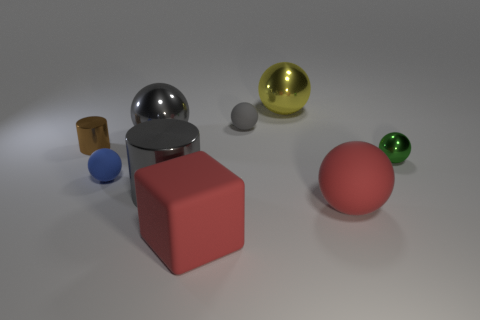Subtract all small matte spheres. How many spheres are left? 4 Subtract all gray cylinders. How many gray spheres are left? 2 Subtract all spheres. How many objects are left? 3 Subtract 4 spheres. How many spheres are left? 2 Add 1 small red metal blocks. How many objects exist? 10 Subtract all green balls. How many balls are left? 5 Subtract all cyan spheres. Subtract all yellow blocks. How many spheres are left? 6 Subtract all small rubber spheres. Subtract all yellow matte things. How many objects are left? 7 Add 6 big metal cylinders. How many big metal cylinders are left? 7 Add 3 green metallic cylinders. How many green metallic cylinders exist? 3 